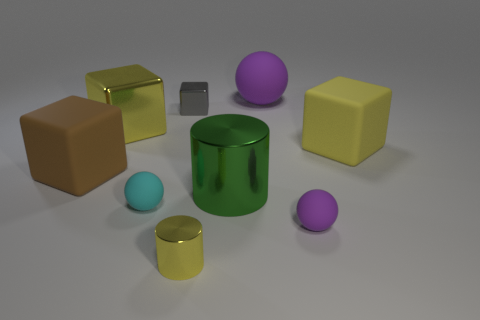Subtract all cubes. How many objects are left? 5 Add 1 tiny cylinders. How many tiny cylinders exist? 2 Subtract 0 red blocks. How many objects are left? 9 Subtract all big purple balls. Subtract all yellow cylinders. How many objects are left? 7 Add 3 big things. How many big things are left? 8 